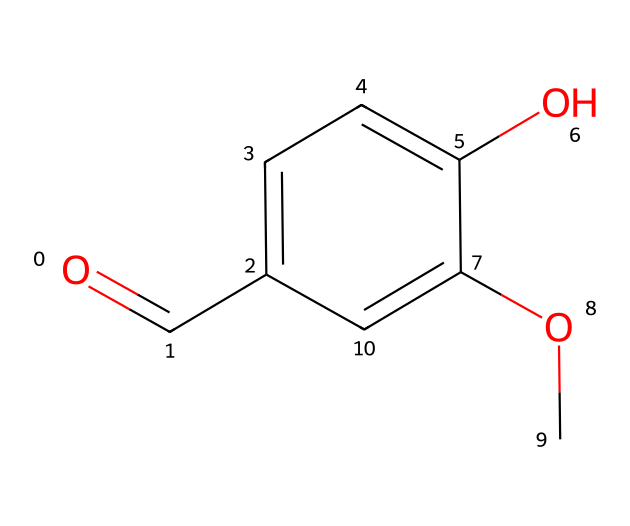What is the functional group present in vanillin? The structure contains a carbonyl group (C=O) at one end, characteristic of aldehydes.
Answer: aldehyde How many carbon atoms are in vanillin? By examining the SMILES, there are eight carbon atoms (C) present in the entire structure.
Answer: 8 What type of aromatic system does vanillin have? The chemical has a phenolic group (benzene ring with a hydroxyl) indicated by the "c" in the SMILES, showing its aromatic nature.
Answer: phenol Which atom in vanillin is involved in the carbonyl group? The carbon atom linked to the oxygen (double bonded) at the beginning of the SMILES indicates the carbonyl part.
Answer: carbon What additional functional group is present apart from the aldehyde in vanillin? Along with the aldehyde, there is a methoxy group (-OCH3) present on the benzene ring as indicated by the "OC" in the SMILES.
Answer: methoxy How many double bonds does vanillin contain? The structure includes one double bond in the carbonyl group of the aldehyde functional group and two in the benzene ring indicated by the symmetry of "c".
Answer: 3 